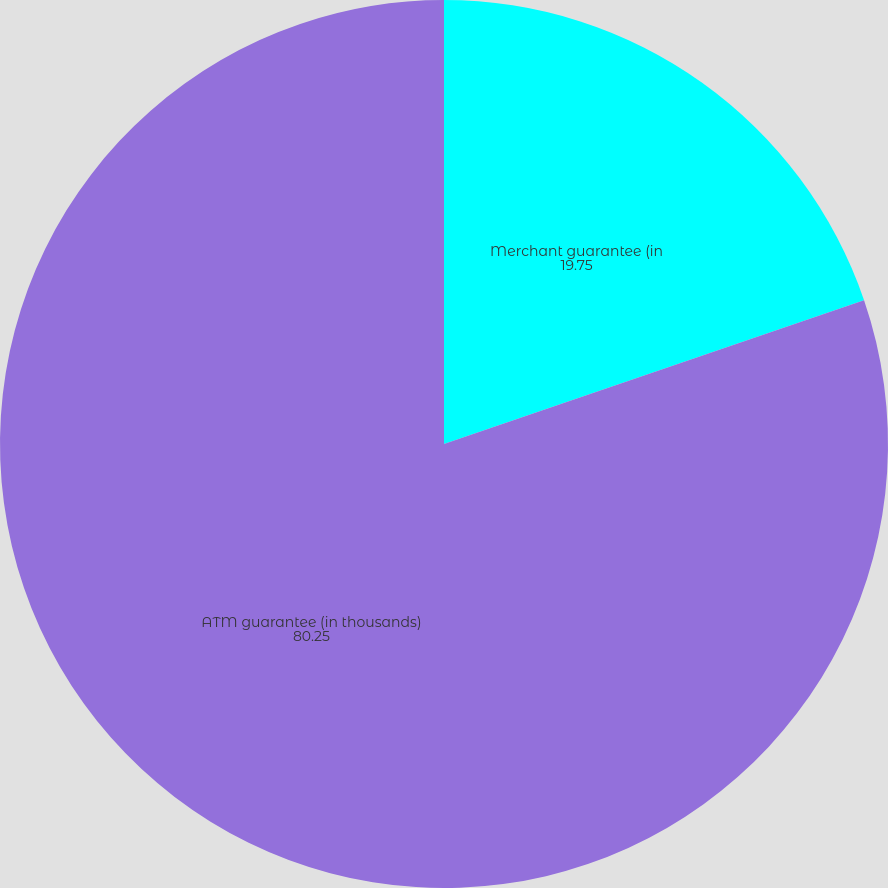<chart> <loc_0><loc_0><loc_500><loc_500><pie_chart><fcel>Merchant guarantee (in<fcel>ATM guarantee (in thousands)<nl><fcel>19.75%<fcel>80.25%<nl></chart> 